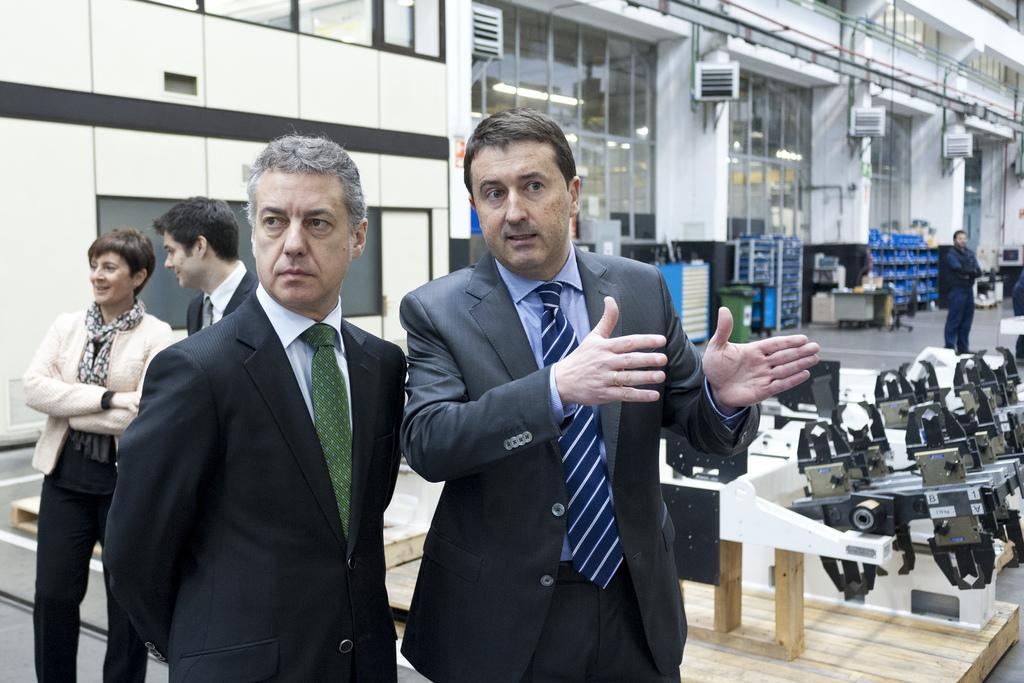What is happening in the center of the image? There are people standing in the center of the image. What can be seen in the background of the image? There is a building with walls and glasses in the background of the image. What is located to the right side of the image? There are some objects to the right side of the image. What route are the people taking in the image? There is no indication of a route or direction the people are taking in the image; they are simply standing in the center. What type of ray is visible in the image? There is no ray present in the image. 